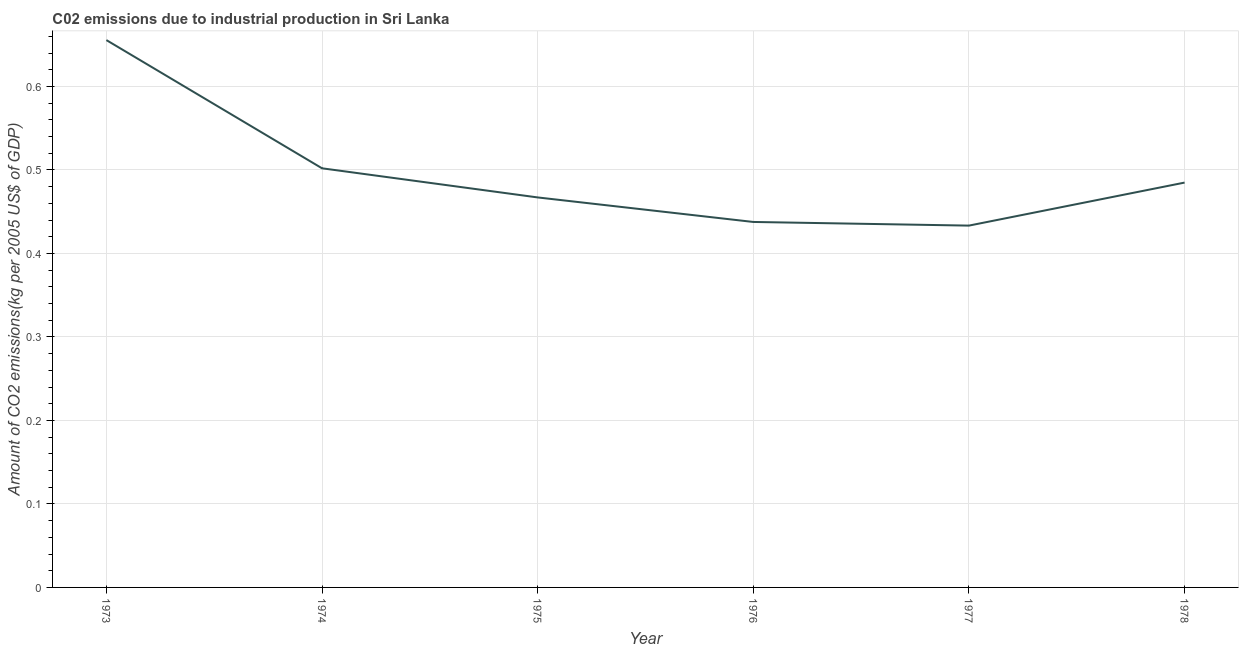What is the amount of co2 emissions in 1976?
Your answer should be very brief. 0.44. Across all years, what is the maximum amount of co2 emissions?
Offer a very short reply. 0.66. Across all years, what is the minimum amount of co2 emissions?
Your answer should be very brief. 0.43. In which year was the amount of co2 emissions maximum?
Give a very brief answer. 1973. In which year was the amount of co2 emissions minimum?
Provide a succinct answer. 1977. What is the sum of the amount of co2 emissions?
Keep it short and to the point. 2.98. What is the difference between the amount of co2 emissions in 1975 and 1977?
Your answer should be very brief. 0.03. What is the average amount of co2 emissions per year?
Make the answer very short. 0.5. What is the median amount of co2 emissions?
Your answer should be very brief. 0.48. Do a majority of the years between 1974 and 1976 (inclusive) have amount of co2 emissions greater than 0.04 kg per 2005 US$ of GDP?
Make the answer very short. Yes. What is the ratio of the amount of co2 emissions in 1974 to that in 1978?
Your answer should be compact. 1.04. What is the difference between the highest and the second highest amount of co2 emissions?
Offer a terse response. 0.15. Is the sum of the amount of co2 emissions in 1973 and 1977 greater than the maximum amount of co2 emissions across all years?
Ensure brevity in your answer.  Yes. What is the difference between the highest and the lowest amount of co2 emissions?
Your answer should be compact. 0.22. In how many years, is the amount of co2 emissions greater than the average amount of co2 emissions taken over all years?
Provide a succinct answer. 2. Does the amount of co2 emissions monotonically increase over the years?
Your answer should be very brief. No. How many years are there in the graph?
Make the answer very short. 6. Does the graph contain any zero values?
Your answer should be very brief. No. Does the graph contain grids?
Your answer should be very brief. Yes. What is the title of the graph?
Your answer should be compact. C02 emissions due to industrial production in Sri Lanka. What is the label or title of the X-axis?
Your answer should be compact. Year. What is the label or title of the Y-axis?
Ensure brevity in your answer.  Amount of CO2 emissions(kg per 2005 US$ of GDP). What is the Amount of CO2 emissions(kg per 2005 US$ of GDP) in 1973?
Keep it short and to the point. 0.66. What is the Amount of CO2 emissions(kg per 2005 US$ of GDP) of 1974?
Keep it short and to the point. 0.5. What is the Amount of CO2 emissions(kg per 2005 US$ of GDP) in 1975?
Offer a very short reply. 0.47. What is the Amount of CO2 emissions(kg per 2005 US$ of GDP) of 1976?
Provide a short and direct response. 0.44. What is the Amount of CO2 emissions(kg per 2005 US$ of GDP) of 1977?
Your answer should be very brief. 0.43. What is the Amount of CO2 emissions(kg per 2005 US$ of GDP) of 1978?
Your answer should be very brief. 0.48. What is the difference between the Amount of CO2 emissions(kg per 2005 US$ of GDP) in 1973 and 1974?
Your answer should be very brief. 0.15. What is the difference between the Amount of CO2 emissions(kg per 2005 US$ of GDP) in 1973 and 1975?
Keep it short and to the point. 0.19. What is the difference between the Amount of CO2 emissions(kg per 2005 US$ of GDP) in 1973 and 1976?
Offer a terse response. 0.22. What is the difference between the Amount of CO2 emissions(kg per 2005 US$ of GDP) in 1973 and 1977?
Your answer should be very brief. 0.22. What is the difference between the Amount of CO2 emissions(kg per 2005 US$ of GDP) in 1973 and 1978?
Offer a terse response. 0.17. What is the difference between the Amount of CO2 emissions(kg per 2005 US$ of GDP) in 1974 and 1975?
Keep it short and to the point. 0.03. What is the difference between the Amount of CO2 emissions(kg per 2005 US$ of GDP) in 1974 and 1976?
Make the answer very short. 0.06. What is the difference between the Amount of CO2 emissions(kg per 2005 US$ of GDP) in 1974 and 1977?
Offer a terse response. 0.07. What is the difference between the Amount of CO2 emissions(kg per 2005 US$ of GDP) in 1974 and 1978?
Provide a succinct answer. 0.02. What is the difference between the Amount of CO2 emissions(kg per 2005 US$ of GDP) in 1975 and 1976?
Your response must be concise. 0.03. What is the difference between the Amount of CO2 emissions(kg per 2005 US$ of GDP) in 1975 and 1977?
Ensure brevity in your answer.  0.03. What is the difference between the Amount of CO2 emissions(kg per 2005 US$ of GDP) in 1975 and 1978?
Your response must be concise. -0.02. What is the difference between the Amount of CO2 emissions(kg per 2005 US$ of GDP) in 1976 and 1977?
Ensure brevity in your answer.  0. What is the difference between the Amount of CO2 emissions(kg per 2005 US$ of GDP) in 1976 and 1978?
Your answer should be very brief. -0.05. What is the difference between the Amount of CO2 emissions(kg per 2005 US$ of GDP) in 1977 and 1978?
Give a very brief answer. -0.05. What is the ratio of the Amount of CO2 emissions(kg per 2005 US$ of GDP) in 1973 to that in 1974?
Provide a short and direct response. 1.31. What is the ratio of the Amount of CO2 emissions(kg per 2005 US$ of GDP) in 1973 to that in 1975?
Provide a succinct answer. 1.4. What is the ratio of the Amount of CO2 emissions(kg per 2005 US$ of GDP) in 1973 to that in 1976?
Provide a short and direct response. 1.5. What is the ratio of the Amount of CO2 emissions(kg per 2005 US$ of GDP) in 1973 to that in 1977?
Offer a very short reply. 1.51. What is the ratio of the Amount of CO2 emissions(kg per 2005 US$ of GDP) in 1973 to that in 1978?
Your answer should be compact. 1.35. What is the ratio of the Amount of CO2 emissions(kg per 2005 US$ of GDP) in 1974 to that in 1975?
Offer a terse response. 1.07. What is the ratio of the Amount of CO2 emissions(kg per 2005 US$ of GDP) in 1974 to that in 1976?
Keep it short and to the point. 1.15. What is the ratio of the Amount of CO2 emissions(kg per 2005 US$ of GDP) in 1974 to that in 1977?
Ensure brevity in your answer.  1.16. What is the ratio of the Amount of CO2 emissions(kg per 2005 US$ of GDP) in 1974 to that in 1978?
Offer a terse response. 1.03. What is the ratio of the Amount of CO2 emissions(kg per 2005 US$ of GDP) in 1975 to that in 1976?
Your response must be concise. 1.07. What is the ratio of the Amount of CO2 emissions(kg per 2005 US$ of GDP) in 1975 to that in 1977?
Give a very brief answer. 1.08. What is the ratio of the Amount of CO2 emissions(kg per 2005 US$ of GDP) in 1976 to that in 1978?
Offer a very short reply. 0.9. What is the ratio of the Amount of CO2 emissions(kg per 2005 US$ of GDP) in 1977 to that in 1978?
Your answer should be compact. 0.89. 